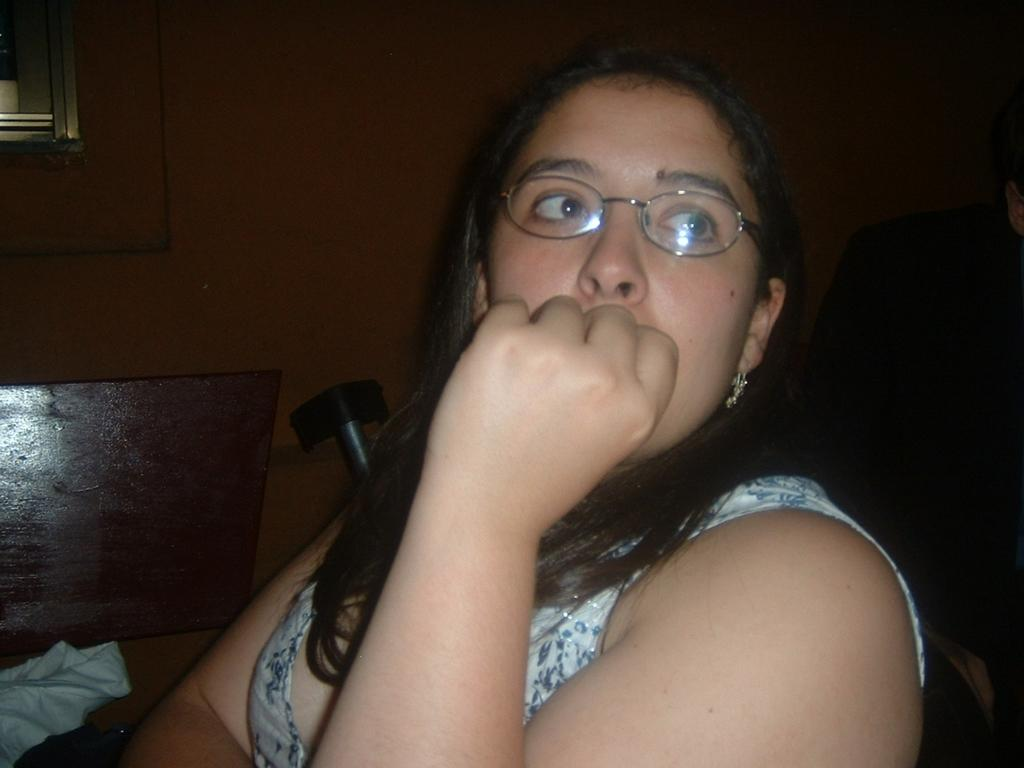Who is present in the image? There is a woman in the image. What is the woman wearing on her face? The woman is wearing spectacles. What can be seen in the background of the image? There is a cloth and other objects in the background of the image. Can you describe any architectural features in the background? Yes, there is a shelf attached to the wall in the background of the image. How many rings is the woman wearing on her fingers in the image? There is no information about rings in the image; the woman is only described as wearing spectacles. 